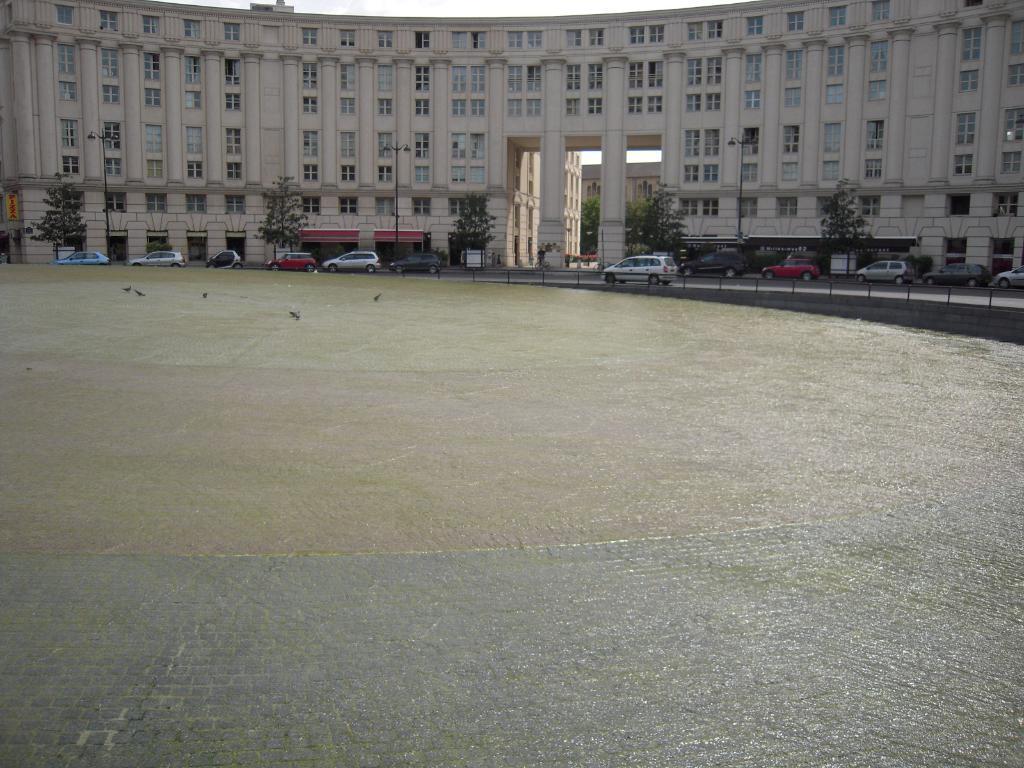Describe this image in one or two sentences. In this image we can see a building, in front of it there are some cars, trees, and there is a fencing, we can see a ground, there are some birds on it, also we can see a board with some text written on it, there are some street light poles, we can also see the sky. 